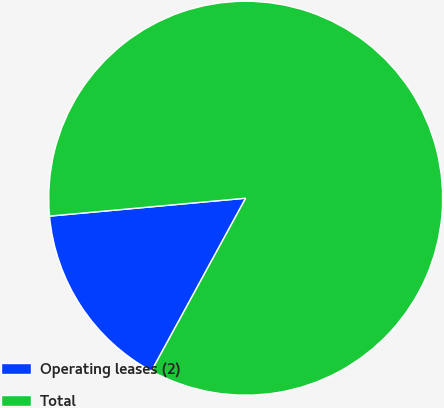Convert chart to OTSL. <chart><loc_0><loc_0><loc_500><loc_500><pie_chart><fcel>Operating leases (2)<fcel>Total<nl><fcel>15.61%<fcel>84.39%<nl></chart> 